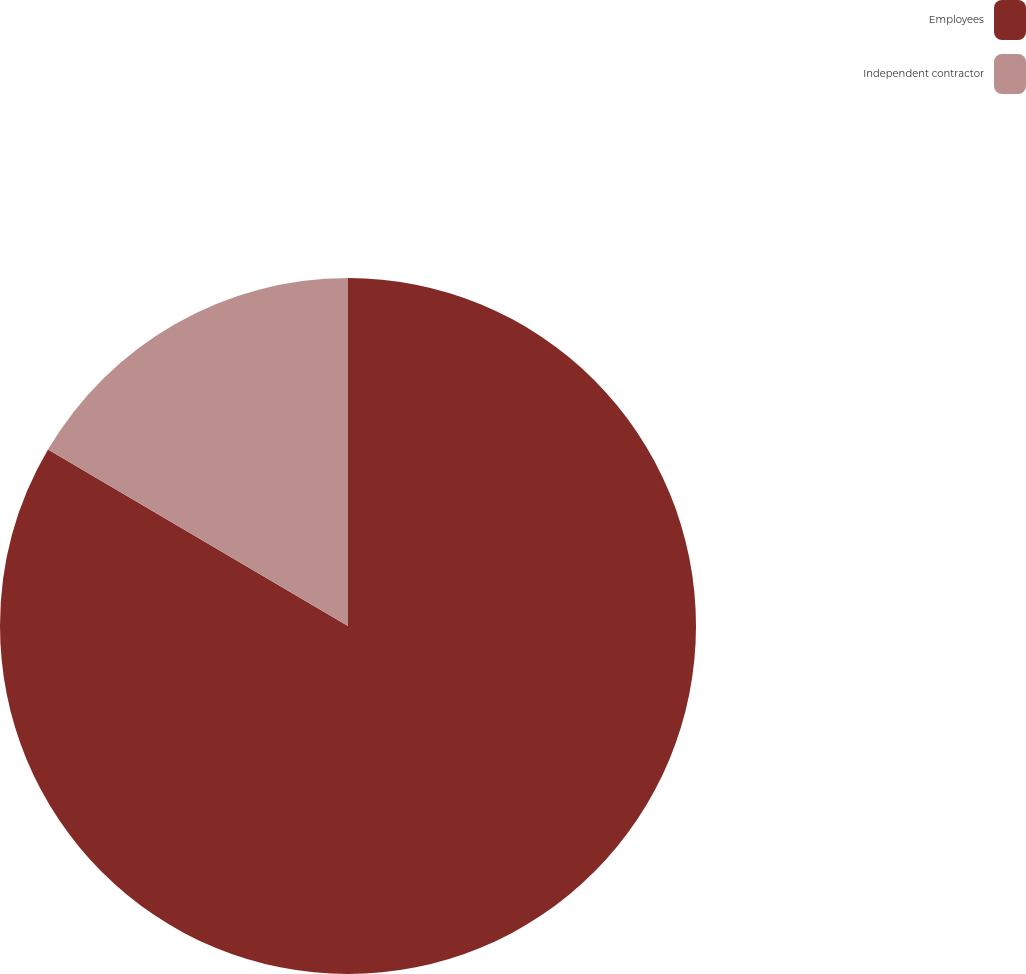Convert chart. <chart><loc_0><loc_0><loc_500><loc_500><pie_chart><fcel>Employees<fcel>Independent contractor<nl><fcel>83.46%<fcel>16.54%<nl></chart> 